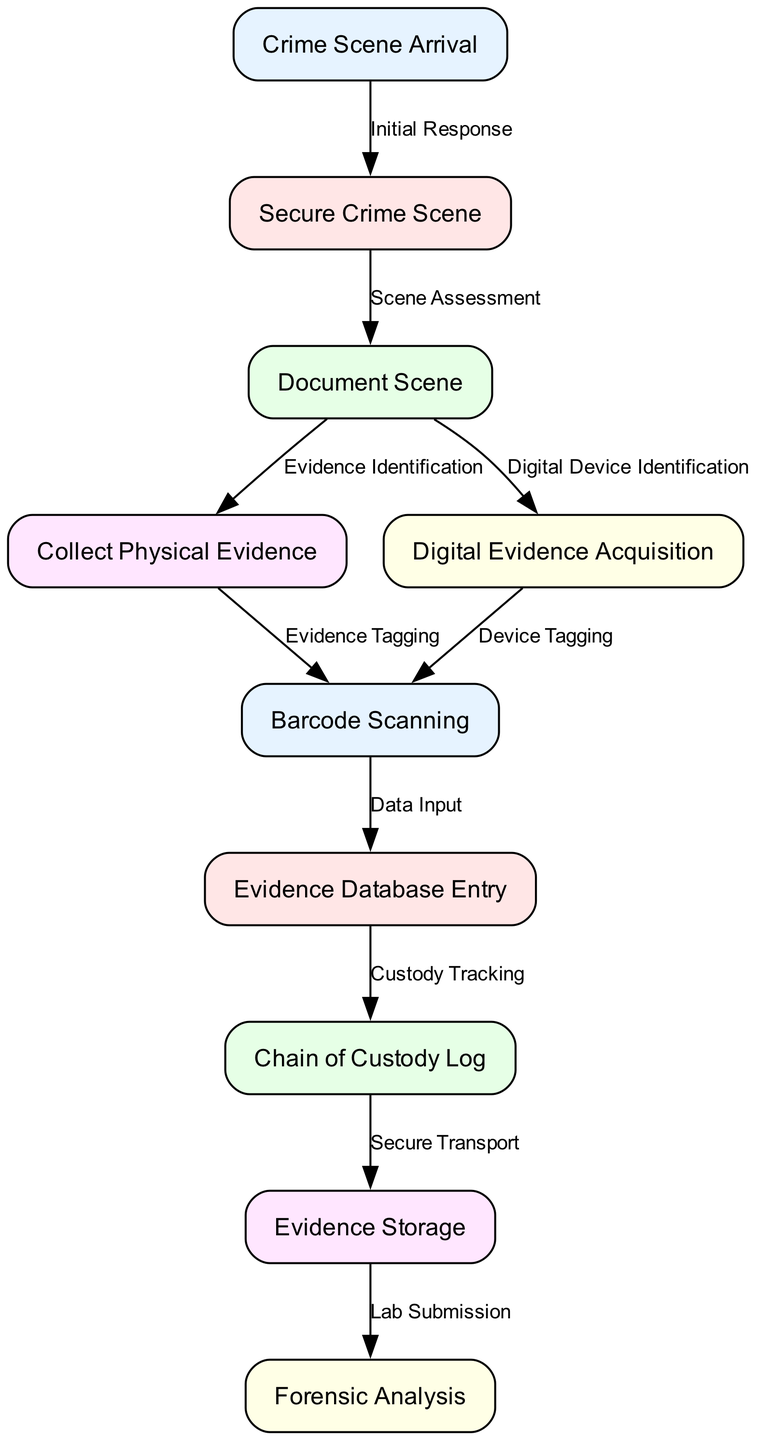What is the first node in the process? The first node in the process is identified as "Crime Scene Arrival." This can be confirmed by locating the node with the ID "1" in the diagram.
Answer: Crime Scene Arrival How many total nodes are present in the diagram? By counting each unique node listed in the diagram data, we can determine that there are ten nodes. This includes all steps from the initial arrival to forensic analysis.
Answer: 10 What step follows the "Secure Crime Scene" node? By checking the edges in the diagram, the step following "Secure Crime Scene" (node ID "2") is "Document Scene" (node ID "3"). This connection is labeled "Scene Assessment" in the edge data.
Answer: Document Scene Which node is responsible for evidence tagging? Evidence tagging is performed at the "Barcode Scanning" node. By examining the flow from "Collect Physical Evidence" (node ID "4") to "Barcode Scanning" (node ID "6"), we see the edge labeled "Evidence Tagging."
Answer: Barcode Scanning What is the last step in the evidence collection process? The last step in the process is "Forensic Analysis," indicated by node ID "10." This can be confirmed as it follows "Evidence Storage" and is the endpoint of the process flow.
Answer: Forensic Analysis How many edges are present in the diagram? By counting the connections (edges) between the nodes defined in the diagram, we see there are nine edges that represent the relationships and transitions between various steps.
Answer: 9 What labeling describes the connection from "Digital Evidence Acquisition" to "Barcode Scanning"? The edge connecting "Digital Evidence Acquisition" (node ID "5") to "Barcode Scanning" (node ID "6") is labeled "Device Tagging." This can be verified by referring to the edge data.
Answer: Device Tagging Which two nodes involve evidence storage? The nodes involved in evidence storage are "Evidence Storage" (node ID "9") and "Chain of Custody Log" (node ID "8"). The flow from "Evidence Database Entry" directly leads to "Chain of Custody Log," which is part of the overall evidence tracking process including secure storage.
Answer: Evidence Storage and Chain of Custody Log What process occurs after evidence database entry? After "Evidence Database Entry" (node ID "7"), the next process is "Chain of Custody Log" (node ID "8"). By following the flow, we see that custody tracking is crucial to managing the chain of evidence.
Answer: Chain of Custody Log 